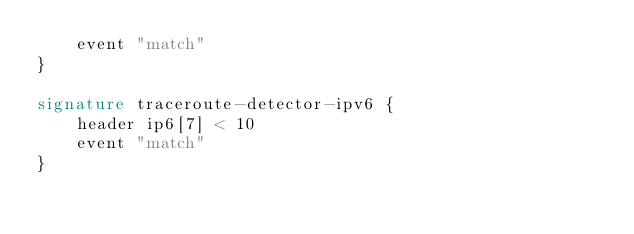Convert code to text. <code><loc_0><loc_0><loc_500><loc_500><_SML_>	event "match"
}

signature traceroute-detector-ipv6 {
	header ip6[7] < 10
	event "match"
}</code> 